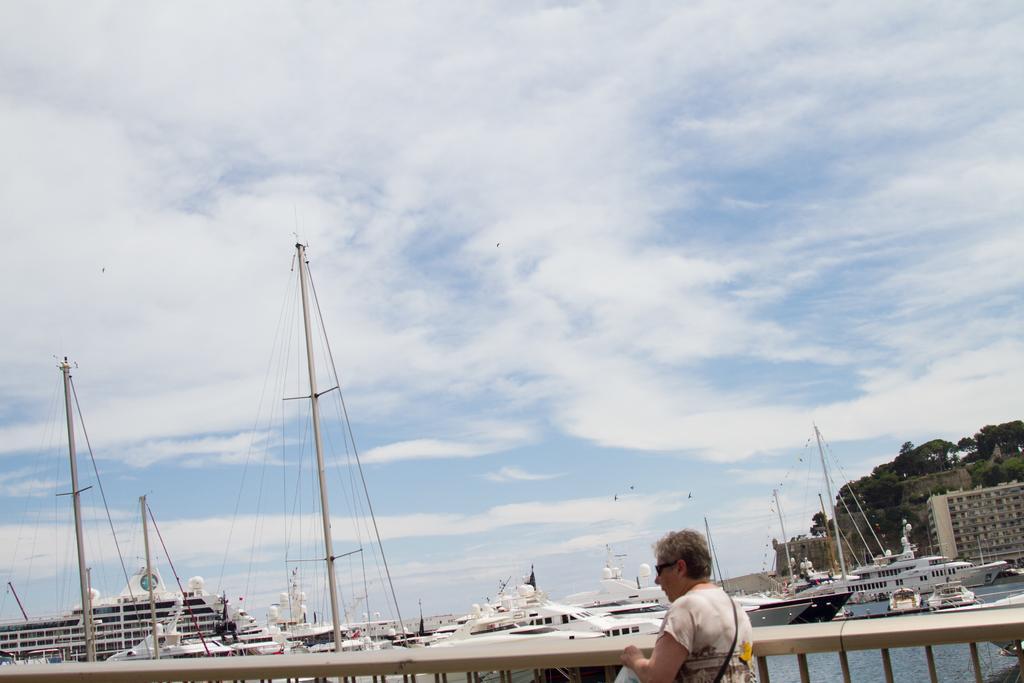Can you describe this image briefly? In this image we can see a person wearing goggles and a bag. On the left side, we can see group of boats placed on the water. To the right side, we can see a building. In the background, we can see a group of trees and a cloudy sky. 